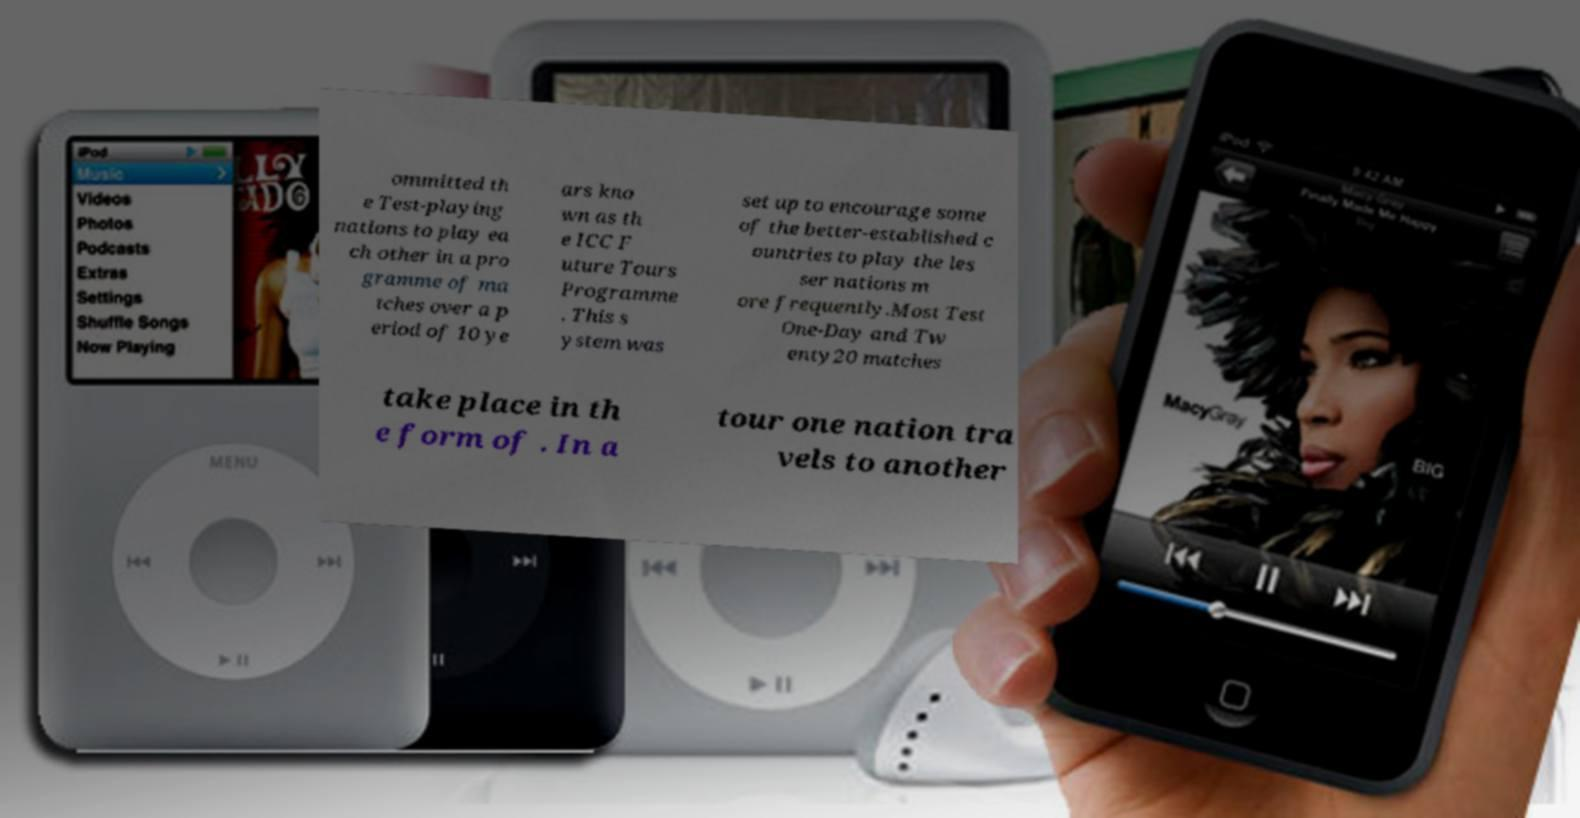I need the written content from this picture converted into text. Can you do that? ommitted th e Test-playing nations to play ea ch other in a pro gramme of ma tches over a p eriod of 10 ye ars kno wn as th e ICC F uture Tours Programme . This s ystem was set up to encourage some of the better-established c ountries to play the les ser nations m ore frequently.Most Test One-Day and Tw enty20 matches take place in th e form of . In a tour one nation tra vels to another 